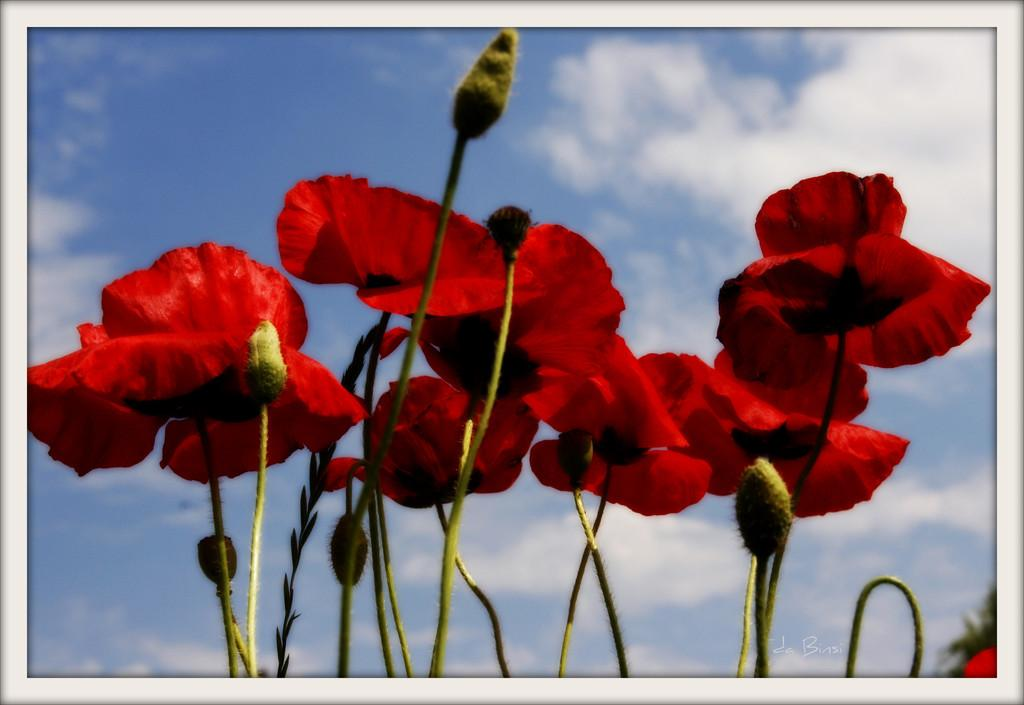What is depicted in the image? There is a picture of red flowers in the image. Can you describe the flowers in more detail? The flowers have buds and stems. What can be seen in the background of the image? There is a cloudy sky in the background of the image. Can you tell me how many balls are visible in the image? There are no balls present in the image; it features a picture of red flowers with a cloudy sky in the background. What type of swing can be seen in the image? There is no swing present in the image. 